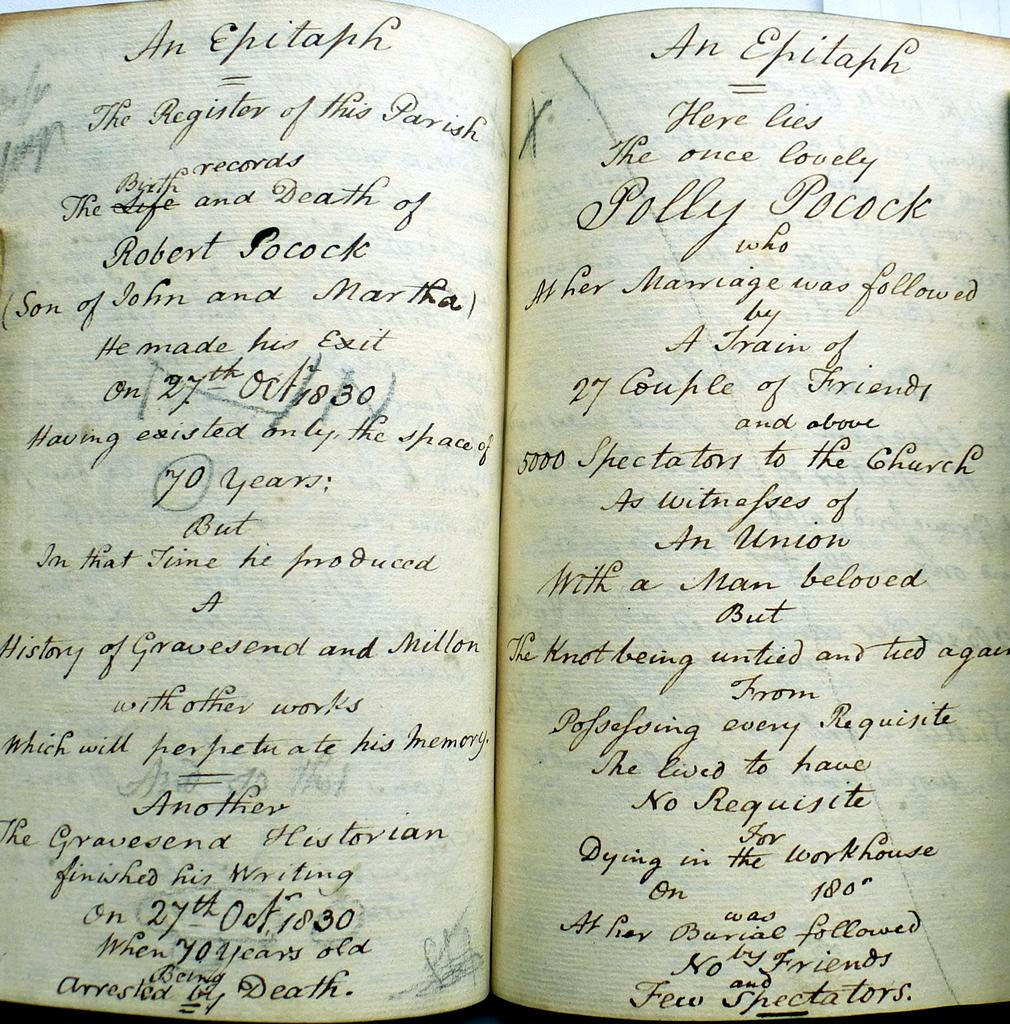<image>
Share a concise interpretation of the image provided. old hand written book sits open pages of an epitaph 